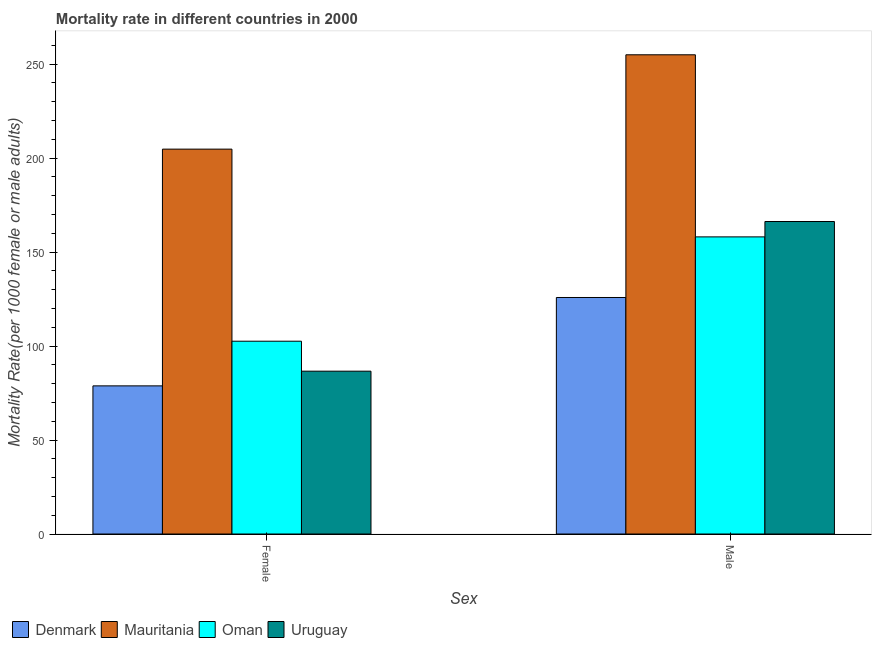How many groups of bars are there?
Provide a succinct answer. 2. Are the number of bars on each tick of the X-axis equal?
Ensure brevity in your answer.  Yes. How many bars are there on the 2nd tick from the left?
Offer a very short reply. 4. How many bars are there on the 2nd tick from the right?
Provide a succinct answer. 4. What is the label of the 2nd group of bars from the left?
Give a very brief answer. Male. What is the female mortality rate in Uruguay?
Keep it short and to the point. 86.64. Across all countries, what is the maximum male mortality rate?
Provide a short and direct response. 255. Across all countries, what is the minimum male mortality rate?
Make the answer very short. 125.85. In which country was the male mortality rate maximum?
Keep it short and to the point. Mauritania. In which country was the female mortality rate minimum?
Offer a terse response. Denmark. What is the total male mortality rate in the graph?
Make the answer very short. 705.23. What is the difference between the male mortality rate in Uruguay and that in Denmark?
Your answer should be compact. 40.43. What is the difference between the female mortality rate in Uruguay and the male mortality rate in Mauritania?
Provide a succinct answer. -168.36. What is the average male mortality rate per country?
Ensure brevity in your answer.  176.31. What is the difference between the male mortality rate and female mortality rate in Denmark?
Provide a short and direct response. 47.03. In how many countries, is the male mortality rate greater than 10 ?
Your answer should be compact. 4. What is the ratio of the male mortality rate in Oman to that in Denmark?
Provide a succinct answer. 1.26. In how many countries, is the male mortality rate greater than the average male mortality rate taken over all countries?
Your response must be concise. 1. What does the 3rd bar from the left in Male represents?
Ensure brevity in your answer.  Oman. What does the 1st bar from the right in Male represents?
Make the answer very short. Uruguay. Are all the bars in the graph horizontal?
Keep it short and to the point. No. Does the graph contain grids?
Make the answer very short. No. What is the title of the graph?
Your response must be concise. Mortality rate in different countries in 2000. What is the label or title of the X-axis?
Provide a short and direct response. Sex. What is the label or title of the Y-axis?
Provide a short and direct response. Mortality Rate(per 1000 female or male adults). What is the Mortality Rate(per 1000 female or male adults) in Denmark in Female?
Provide a succinct answer. 78.83. What is the Mortality Rate(per 1000 female or male adults) in Mauritania in Female?
Keep it short and to the point. 204.8. What is the Mortality Rate(per 1000 female or male adults) in Oman in Female?
Keep it short and to the point. 102.59. What is the Mortality Rate(per 1000 female or male adults) of Uruguay in Female?
Ensure brevity in your answer.  86.64. What is the Mortality Rate(per 1000 female or male adults) of Denmark in Male?
Offer a very short reply. 125.85. What is the Mortality Rate(per 1000 female or male adults) of Mauritania in Male?
Give a very brief answer. 255. What is the Mortality Rate(per 1000 female or male adults) of Oman in Male?
Offer a very short reply. 158.1. What is the Mortality Rate(per 1000 female or male adults) in Uruguay in Male?
Your response must be concise. 166.28. Across all Sex, what is the maximum Mortality Rate(per 1000 female or male adults) of Denmark?
Ensure brevity in your answer.  125.85. Across all Sex, what is the maximum Mortality Rate(per 1000 female or male adults) in Mauritania?
Your answer should be very brief. 255. Across all Sex, what is the maximum Mortality Rate(per 1000 female or male adults) of Oman?
Ensure brevity in your answer.  158.1. Across all Sex, what is the maximum Mortality Rate(per 1000 female or male adults) in Uruguay?
Provide a short and direct response. 166.28. Across all Sex, what is the minimum Mortality Rate(per 1000 female or male adults) of Denmark?
Your answer should be very brief. 78.83. Across all Sex, what is the minimum Mortality Rate(per 1000 female or male adults) in Mauritania?
Give a very brief answer. 204.8. Across all Sex, what is the minimum Mortality Rate(per 1000 female or male adults) in Oman?
Your answer should be very brief. 102.59. Across all Sex, what is the minimum Mortality Rate(per 1000 female or male adults) in Uruguay?
Offer a very short reply. 86.64. What is the total Mortality Rate(per 1000 female or male adults) of Denmark in the graph?
Your answer should be very brief. 204.68. What is the total Mortality Rate(per 1000 female or male adults) in Mauritania in the graph?
Your response must be concise. 459.8. What is the total Mortality Rate(per 1000 female or male adults) of Oman in the graph?
Provide a succinct answer. 260.69. What is the total Mortality Rate(per 1000 female or male adults) of Uruguay in the graph?
Offer a very short reply. 252.92. What is the difference between the Mortality Rate(per 1000 female or male adults) in Denmark in Female and that in Male?
Make the answer very short. -47.02. What is the difference between the Mortality Rate(per 1000 female or male adults) in Mauritania in Female and that in Male?
Your answer should be very brief. -50.2. What is the difference between the Mortality Rate(per 1000 female or male adults) of Oman in Female and that in Male?
Your answer should be compact. -55.51. What is the difference between the Mortality Rate(per 1000 female or male adults) in Uruguay in Female and that in Male?
Your answer should be very brief. -79.64. What is the difference between the Mortality Rate(per 1000 female or male adults) in Denmark in Female and the Mortality Rate(per 1000 female or male adults) in Mauritania in Male?
Your response must be concise. -176.17. What is the difference between the Mortality Rate(per 1000 female or male adults) of Denmark in Female and the Mortality Rate(per 1000 female or male adults) of Oman in Male?
Ensure brevity in your answer.  -79.27. What is the difference between the Mortality Rate(per 1000 female or male adults) in Denmark in Female and the Mortality Rate(per 1000 female or male adults) in Uruguay in Male?
Your response must be concise. -87.45. What is the difference between the Mortality Rate(per 1000 female or male adults) in Mauritania in Female and the Mortality Rate(per 1000 female or male adults) in Oman in Male?
Give a very brief answer. 46.7. What is the difference between the Mortality Rate(per 1000 female or male adults) of Mauritania in Female and the Mortality Rate(per 1000 female or male adults) of Uruguay in Male?
Offer a very short reply. 38.52. What is the difference between the Mortality Rate(per 1000 female or male adults) in Oman in Female and the Mortality Rate(per 1000 female or male adults) in Uruguay in Male?
Offer a very short reply. -63.7. What is the average Mortality Rate(per 1000 female or male adults) of Denmark per Sex?
Offer a terse response. 102.34. What is the average Mortality Rate(per 1000 female or male adults) in Mauritania per Sex?
Provide a short and direct response. 229.9. What is the average Mortality Rate(per 1000 female or male adults) of Oman per Sex?
Offer a terse response. 130.34. What is the average Mortality Rate(per 1000 female or male adults) of Uruguay per Sex?
Your response must be concise. 126.46. What is the difference between the Mortality Rate(per 1000 female or male adults) of Denmark and Mortality Rate(per 1000 female or male adults) of Mauritania in Female?
Your response must be concise. -125.97. What is the difference between the Mortality Rate(per 1000 female or male adults) in Denmark and Mortality Rate(per 1000 female or male adults) in Oman in Female?
Offer a very short reply. -23.76. What is the difference between the Mortality Rate(per 1000 female or male adults) in Denmark and Mortality Rate(per 1000 female or male adults) in Uruguay in Female?
Provide a short and direct response. -7.81. What is the difference between the Mortality Rate(per 1000 female or male adults) of Mauritania and Mortality Rate(per 1000 female or male adults) of Oman in Female?
Provide a succinct answer. 102.21. What is the difference between the Mortality Rate(per 1000 female or male adults) of Mauritania and Mortality Rate(per 1000 female or male adults) of Uruguay in Female?
Offer a terse response. 118.16. What is the difference between the Mortality Rate(per 1000 female or male adults) of Oman and Mortality Rate(per 1000 female or male adults) of Uruguay in Female?
Your answer should be very brief. 15.95. What is the difference between the Mortality Rate(per 1000 female or male adults) in Denmark and Mortality Rate(per 1000 female or male adults) in Mauritania in Male?
Give a very brief answer. -129.15. What is the difference between the Mortality Rate(per 1000 female or male adults) in Denmark and Mortality Rate(per 1000 female or male adults) in Oman in Male?
Provide a short and direct response. -32.25. What is the difference between the Mortality Rate(per 1000 female or male adults) in Denmark and Mortality Rate(per 1000 female or male adults) in Uruguay in Male?
Your response must be concise. -40.43. What is the difference between the Mortality Rate(per 1000 female or male adults) of Mauritania and Mortality Rate(per 1000 female or male adults) of Oman in Male?
Give a very brief answer. 96.9. What is the difference between the Mortality Rate(per 1000 female or male adults) in Mauritania and Mortality Rate(per 1000 female or male adults) in Uruguay in Male?
Give a very brief answer. 88.72. What is the difference between the Mortality Rate(per 1000 female or male adults) of Oman and Mortality Rate(per 1000 female or male adults) of Uruguay in Male?
Your answer should be compact. -8.18. What is the ratio of the Mortality Rate(per 1000 female or male adults) of Denmark in Female to that in Male?
Your answer should be compact. 0.63. What is the ratio of the Mortality Rate(per 1000 female or male adults) in Mauritania in Female to that in Male?
Provide a succinct answer. 0.8. What is the ratio of the Mortality Rate(per 1000 female or male adults) in Oman in Female to that in Male?
Your answer should be compact. 0.65. What is the ratio of the Mortality Rate(per 1000 female or male adults) in Uruguay in Female to that in Male?
Your answer should be compact. 0.52. What is the difference between the highest and the second highest Mortality Rate(per 1000 female or male adults) in Denmark?
Your answer should be very brief. 47.02. What is the difference between the highest and the second highest Mortality Rate(per 1000 female or male adults) in Mauritania?
Keep it short and to the point. 50.2. What is the difference between the highest and the second highest Mortality Rate(per 1000 female or male adults) of Oman?
Your response must be concise. 55.51. What is the difference between the highest and the second highest Mortality Rate(per 1000 female or male adults) of Uruguay?
Ensure brevity in your answer.  79.64. What is the difference between the highest and the lowest Mortality Rate(per 1000 female or male adults) of Denmark?
Offer a terse response. 47.02. What is the difference between the highest and the lowest Mortality Rate(per 1000 female or male adults) of Mauritania?
Keep it short and to the point. 50.2. What is the difference between the highest and the lowest Mortality Rate(per 1000 female or male adults) of Oman?
Provide a succinct answer. 55.51. What is the difference between the highest and the lowest Mortality Rate(per 1000 female or male adults) in Uruguay?
Make the answer very short. 79.64. 